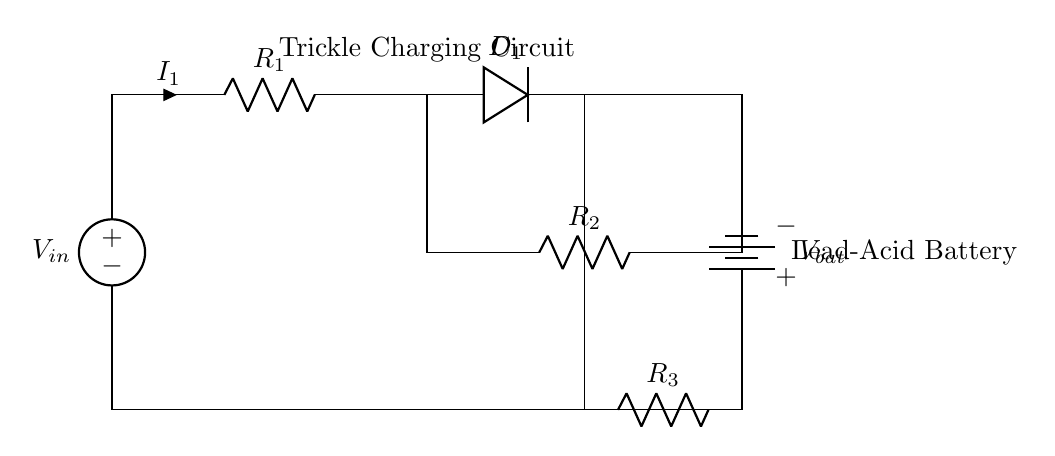What is the main function of this circuit? The circuit is designed for trickle charging a lead-acid battery, providing a constant low current to keep the battery charged without overcharging it.
Answer: Trickle charging What component is used to prevent reverse current flow? The diode in the circuit serves the purpose of allowing current to flow in one direction only, preventing any reverse flow which could damage the battery.
Answer: Diode What type of battery is depicted in this circuit? The circuit specifically mentions a lead-acid battery, which is a common type of rechargeable battery used in various applications.
Answer: Lead-acid battery What does R1 represent in the circuit? R1 is a resistor that limits the current flowing from the voltage source into the circuit, helping to control the charging rate.
Answer: Resistor How is the current labeled in the circuit? The current flowing through the resistor R1 is labeled as I1, indicating that it is the main current drawn by the circuit.
Answer: I1 What happens if the resistor values are decreased? Decreasing the resistor values would increase the current flowing to the battery, which could lead to overcharging and possibly damage the battery.
Answer: Overcharging risk Is there a parallel connection in the circuit? Yes, there is a parallel connection present between battery and resistor R2, allowing the capacitor to charge while maintaining a current path for batteries.
Answer: Yes, between battery and R2 